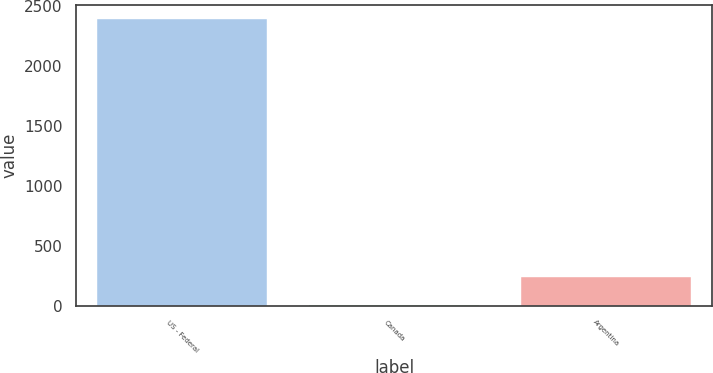<chart> <loc_0><loc_0><loc_500><loc_500><bar_chart><fcel>US - Federal<fcel>Canada<fcel>Argentina<nl><fcel>2393<fcel>6<fcel>244.7<nl></chart> 